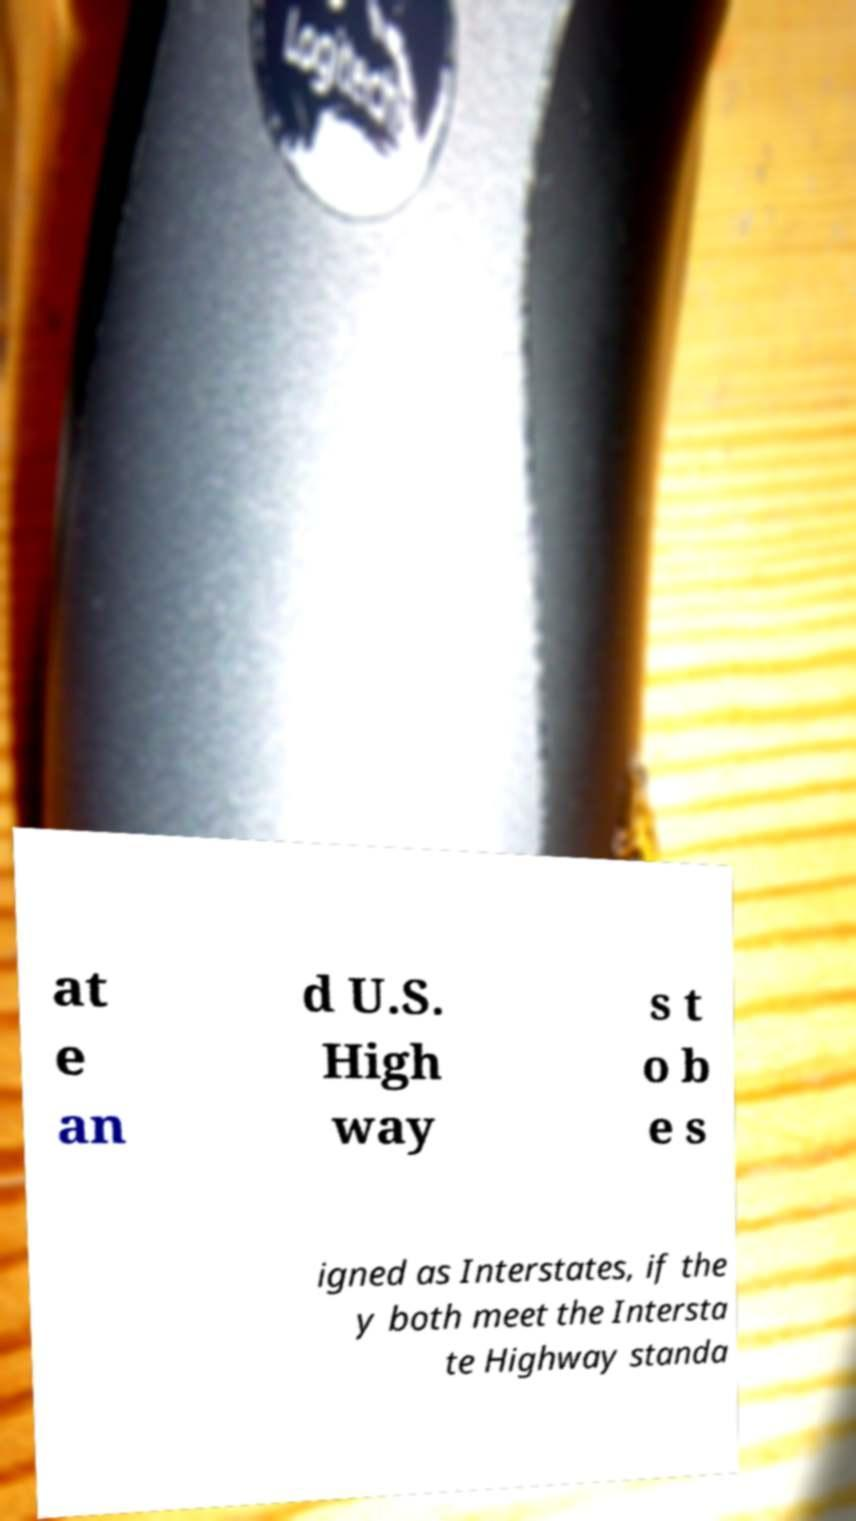Can you read and provide the text displayed in the image?This photo seems to have some interesting text. Can you extract and type it out for me? at e an d U.S. High way s t o b e s igned as Interstates, if the y both meet the Intersta te Highway standa 